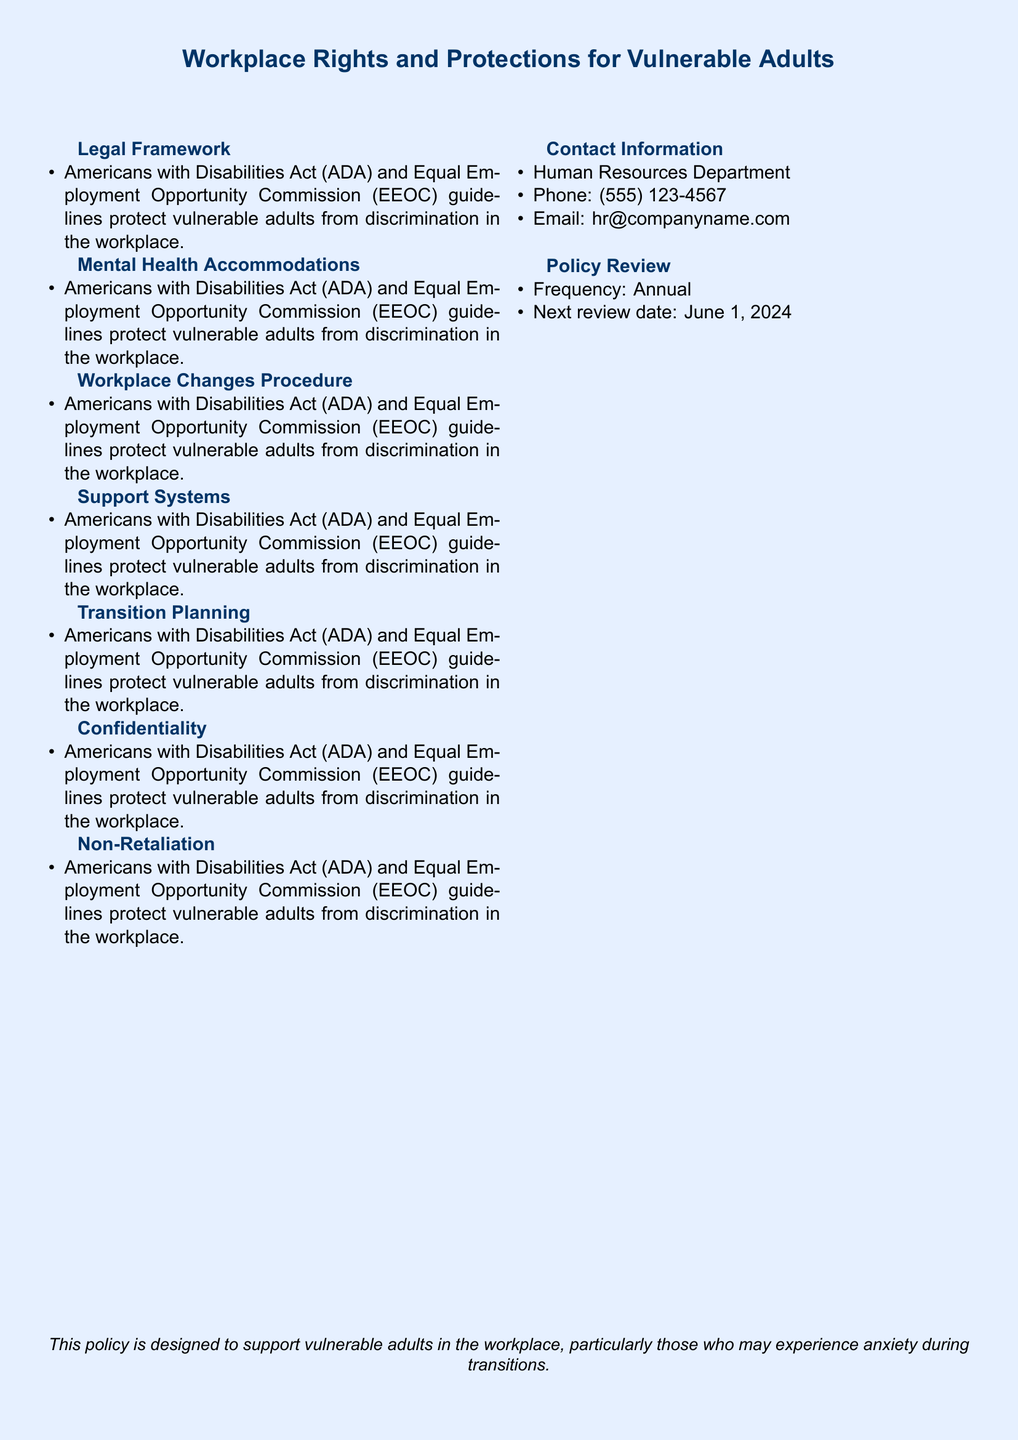What does ADA stand for? ADA stands for the Americans with Disabilities Act, protecting vulnerable adults from discrimination in the workplace.
Answer: Americans with Disabilities Act What kind of help can employees request? Employees can request reasonable accommodations to manage anxiety during transitions.
Answer: Flexible schedules How much notice will Human Resources provide for changes? Human Resources will provide a minimum of two weeks' notice for any significant workplace changes.
Answer: Two weeks What organization offers counseling support? The Employee Assistance Programs (EAP) for counseling and mental health support is provided by Magellan Health Services.
Answer: Magellan Health Services What planning support will be provided for major changes? Managers will work with vulnerable employees to create individualized transition plans for major workplace changes.
Answer: Individualized transition plans How often will the policy be reviewed? The policy will be reviewed annually.
Answer: Annual What is the next review date for the policy? The next review date for the policy is June 1, 2024.
Answer: June 1, 2024 What should be kept confidential according to the policy? All mental health-related information and accommodation requests must be kept strictly confidential.
Answer: Confidentiality 